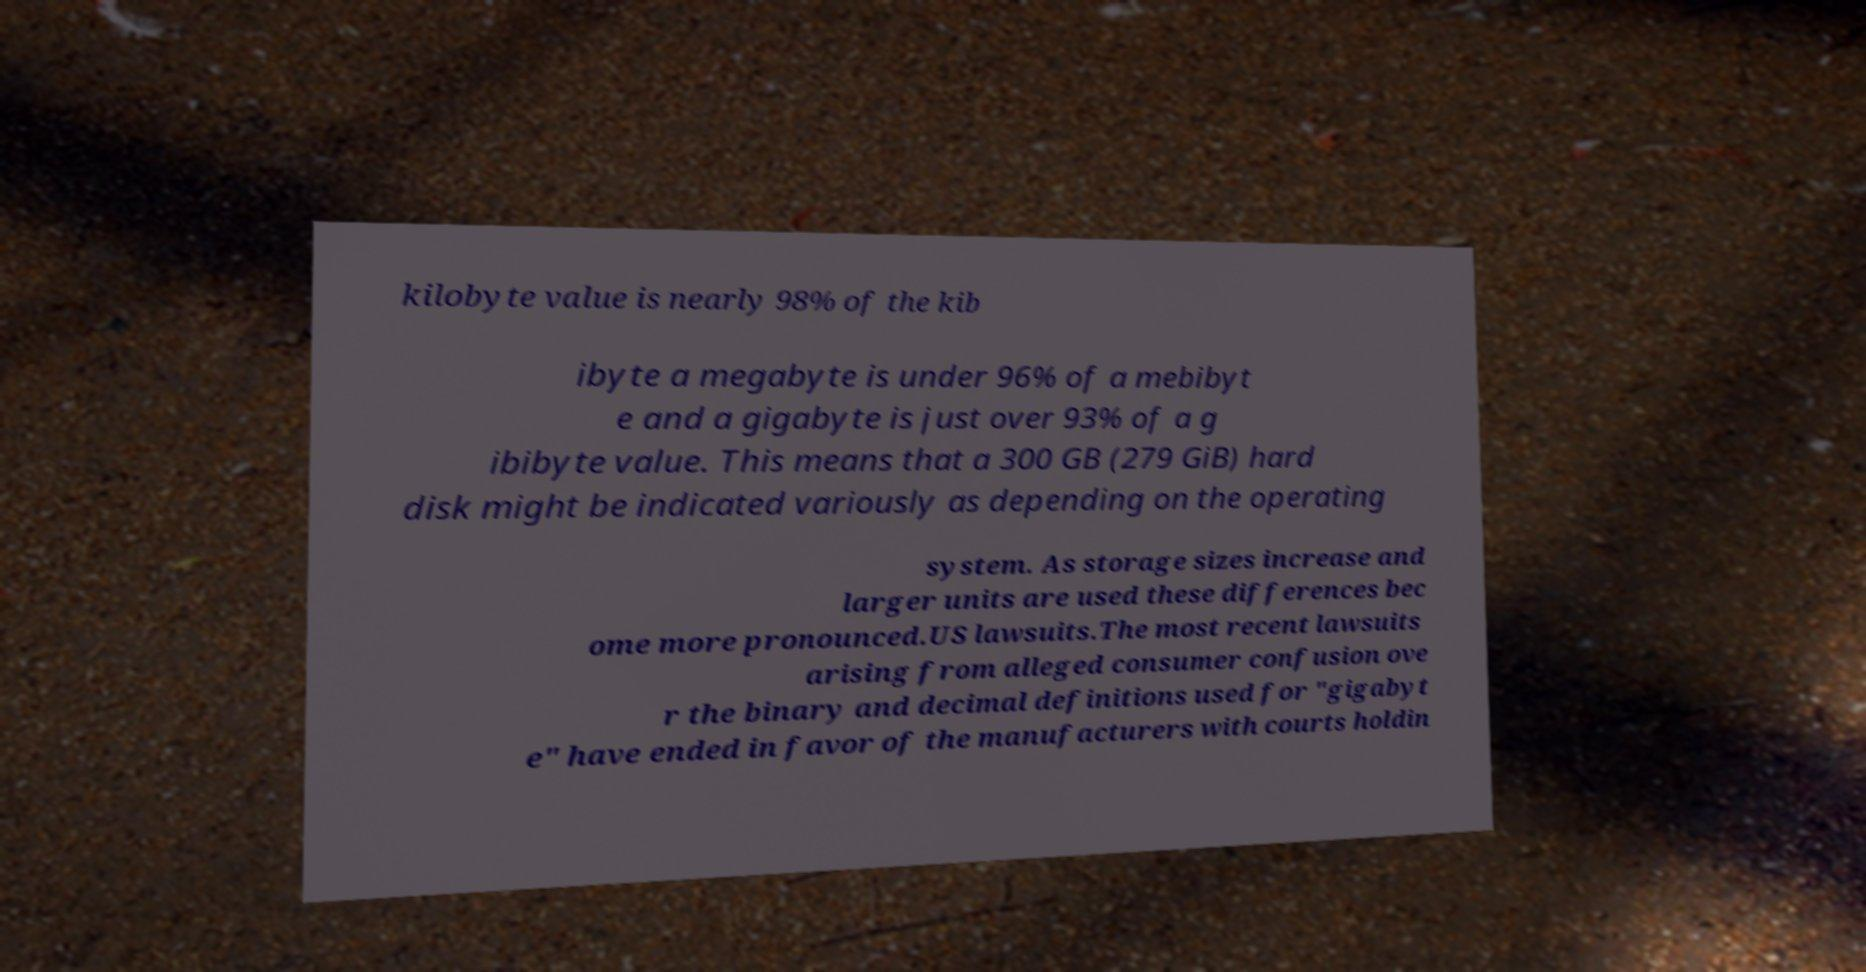Can you accurately transcribe the text from the provided image for me? kilobyte value is nearly 98% of the kib ibyte a megabyte is under 96% of a mebibyt e and a gigabyte is just over 93% of a g ibibyte value. This means that a 300 GB (279 GiB) hard disk might be indicated variously as depending on the operating system. As storage sizes increase and larger units are used these differences bec ome more pronounced.US lawsuits.The most recent lawsuits arising from alleged consumer confusion ove r the binary and decimal definitions used for "gigabyt e" have ended in favor of the manufacturers with courts holdin 